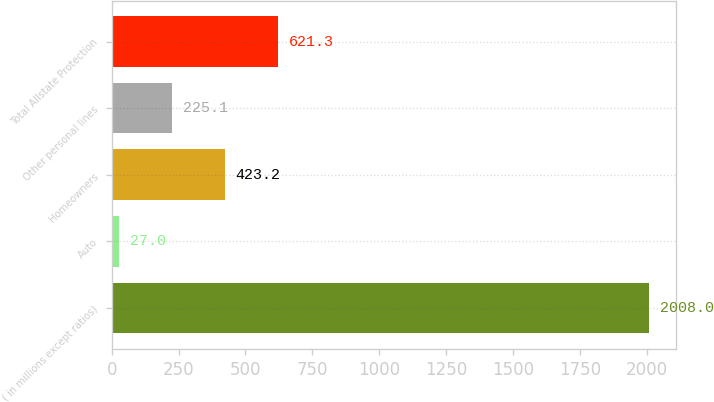Convert chart to OTSL. <chart><loc_0><loc_0><loc_500><loc_500><bar_chart><fcel>( in millions except ratios)<fcel>Auto<fcel>Homeowners<fcel>Other personal lines<fcel>Total Allstate Protection<nl><fcel>2008<fcel>27<fcel>423.2<fcel>225.1<fcel>621.3<nl></chart> 